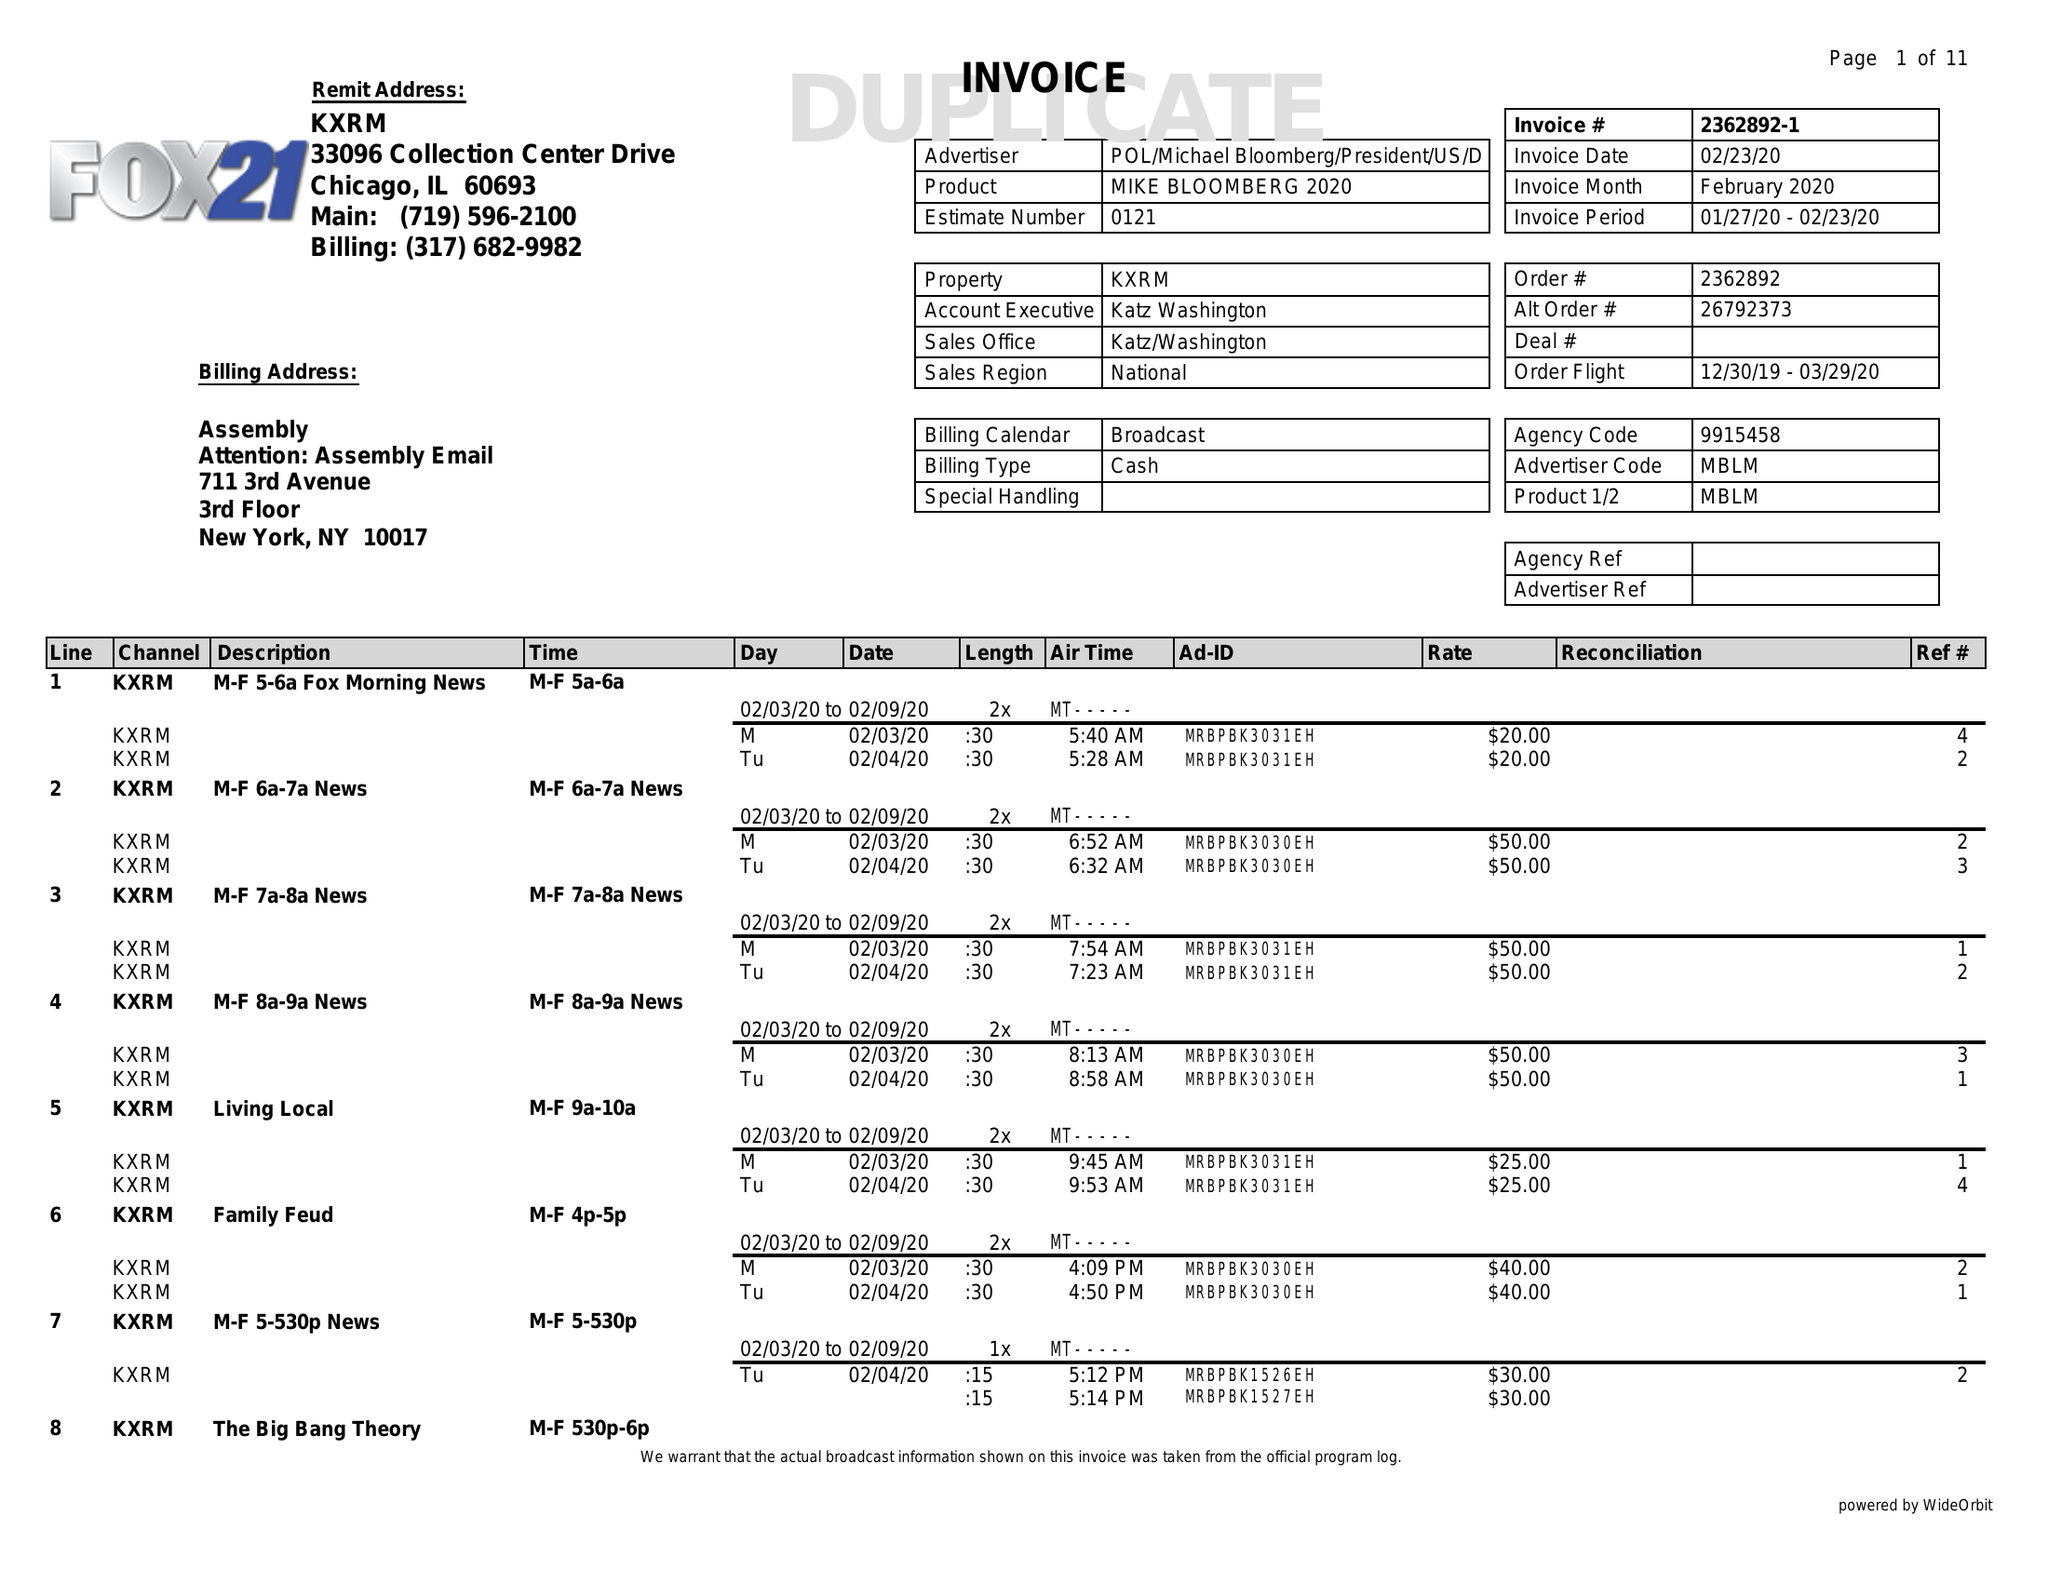What is the value for the flight_from?
Answer the question using a single word or phrase. 12/30/19 